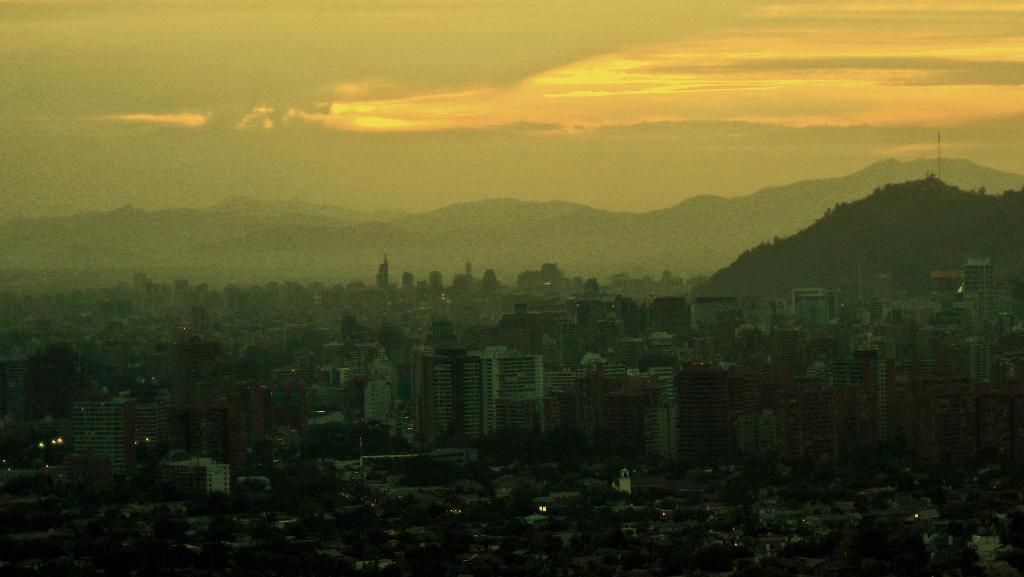What type of structures can be seen in the image? There are buildings in the image. What natural elements are present in the image? There are trees and mountains in the image. What is visible in the background of the image? The sky is visible in the background of the image. What can be observed in the sky? Clouds are present in the sky. What type of railway can be seen in the image? There is no railway present in the image. How many wheels are visible on the buildings in the image? Buildings do not have wheels, so this question cannot be answered based on the image. 